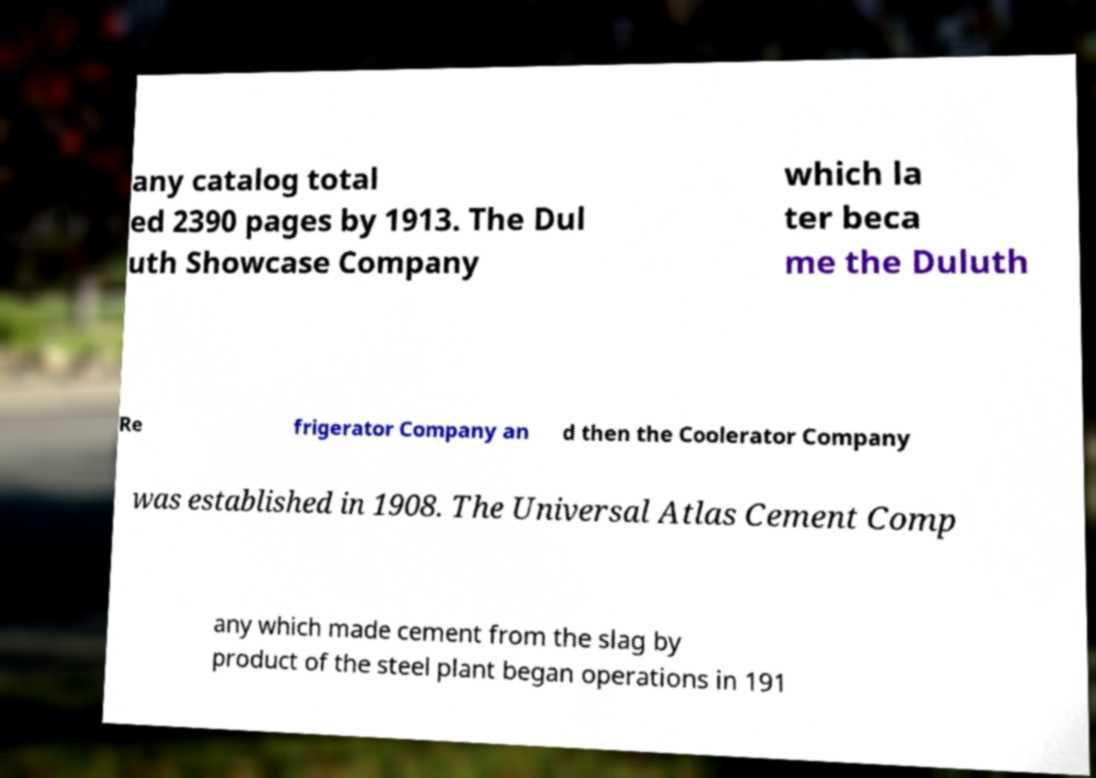Can you read and provide the text displayed in the image?This photo seems to have some interesting text. Can you extract and type it out for me? any catalog total ed 2390 pages by 1913. The Dul uth Showcase Company which la ter beca me the Duluth Re frigerator Company an d then the Coolerator Company was established in 1908. The Universal Atlas Cement Comp any which made cement from the slag by product of the steel plant began operations in 191 